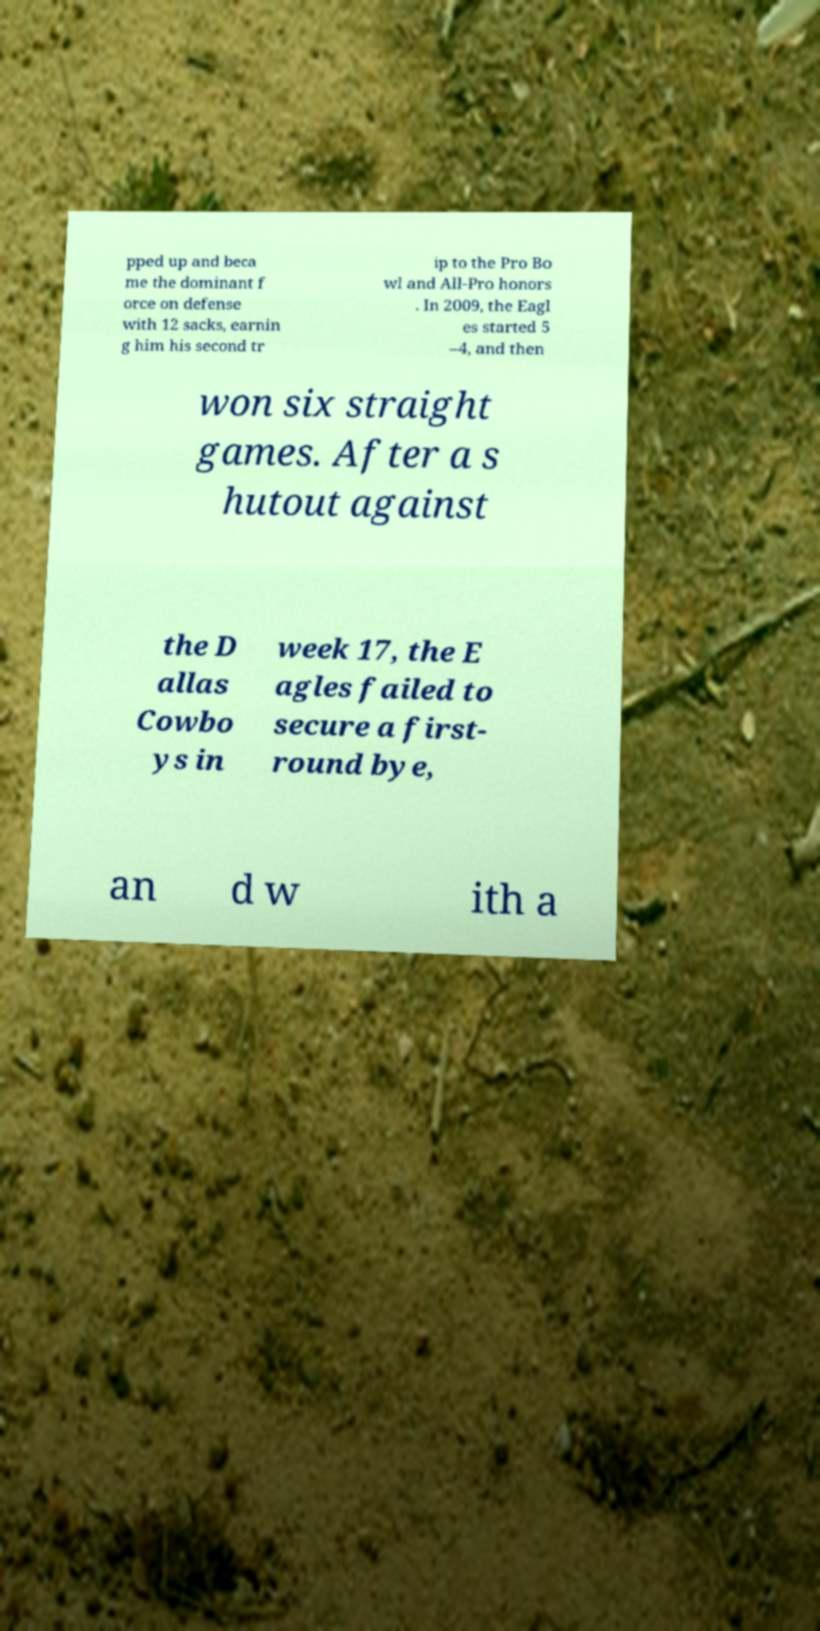What messages or text are displayed in this image? I need them in a readable, typed format. pped up and beca me the dominant f orce on defense with 12 sacks, earnin g him his second tr ip to the Pro Bo wl and All-Pro honors . In 2009, the Eagl es started 5 –4, and then won six straight games. After a s hutout against the D allas Cowbo ys in week 17, the E agles failed to secure a first- round bye, an d w ith a 